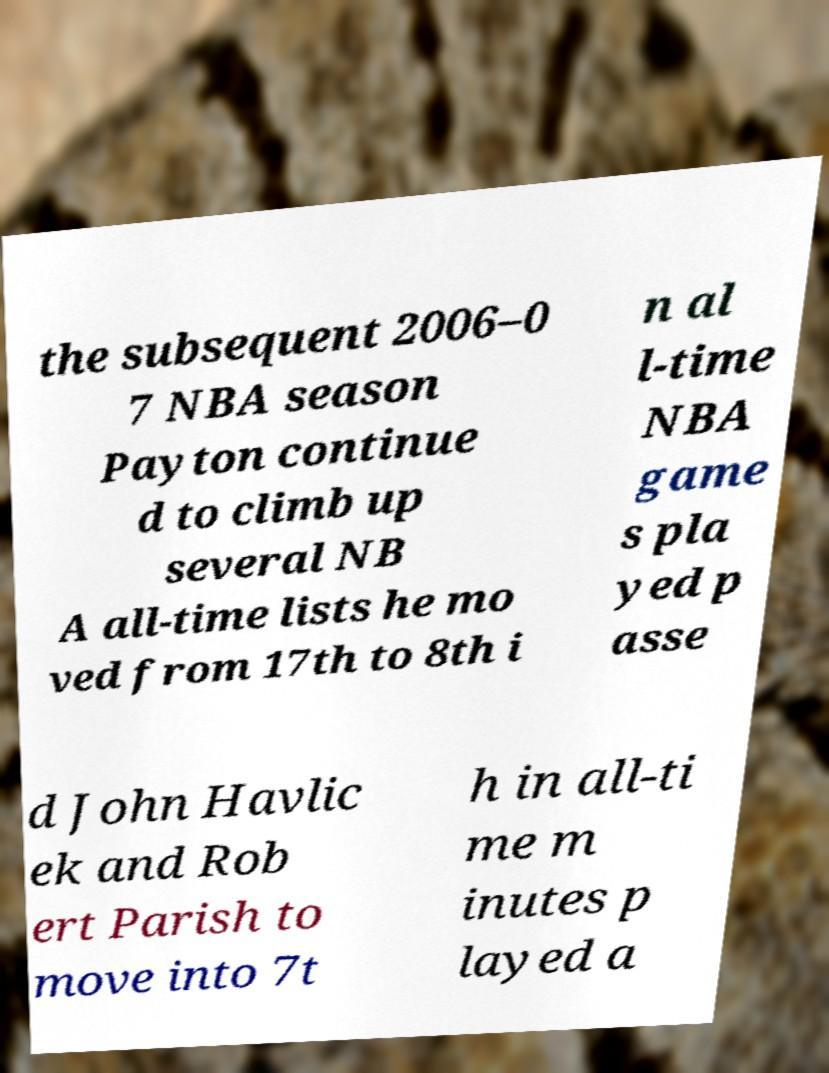What messages or text are displayed in this image? I need them in a readable, typed format. the subsequent 2006–0 7 NBA season Payton continue d to climb up several NB A all-time lists he mo ved from 17th to 8th i n al l-time NBA game s pla yed p asse d John Havlic ek and Rob ert Parish to move into 7t h in all-ti me m inutes p layed a 